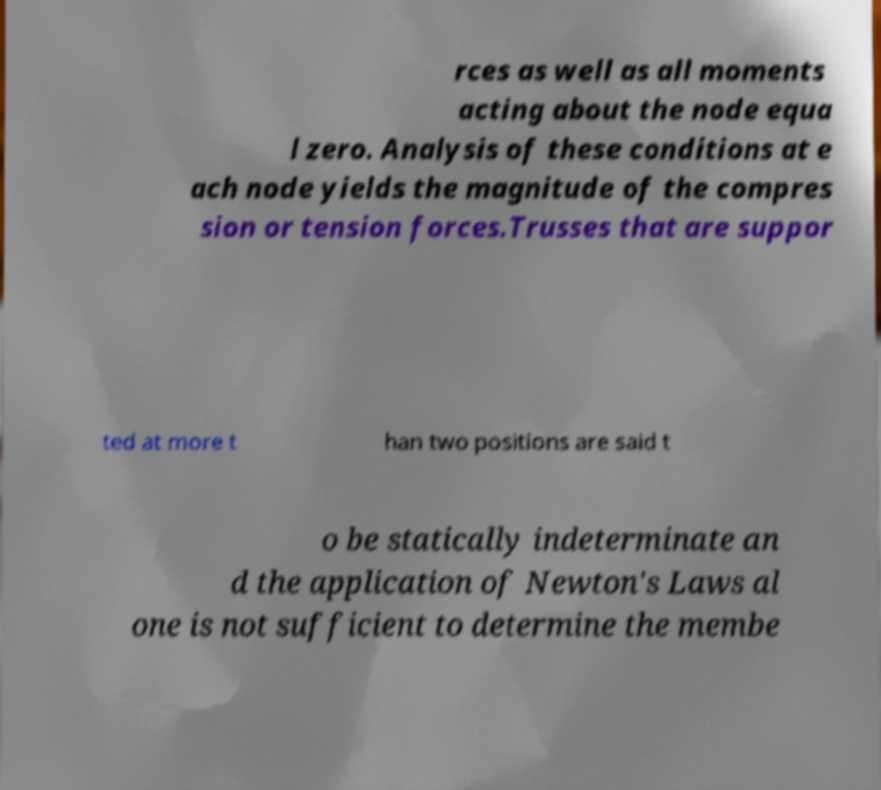Could you extract and type out the text from this image? rces as well as all moments acting about the node equa l zero. Analysis of these conditions at e ach node yields the magnitude of the compres sion or tension forces.Trusses that are suppor ted at more t han two positions are said t o be statically indeterminate an d the application of Newton's Laws al one is not sufficient to determine the membe 